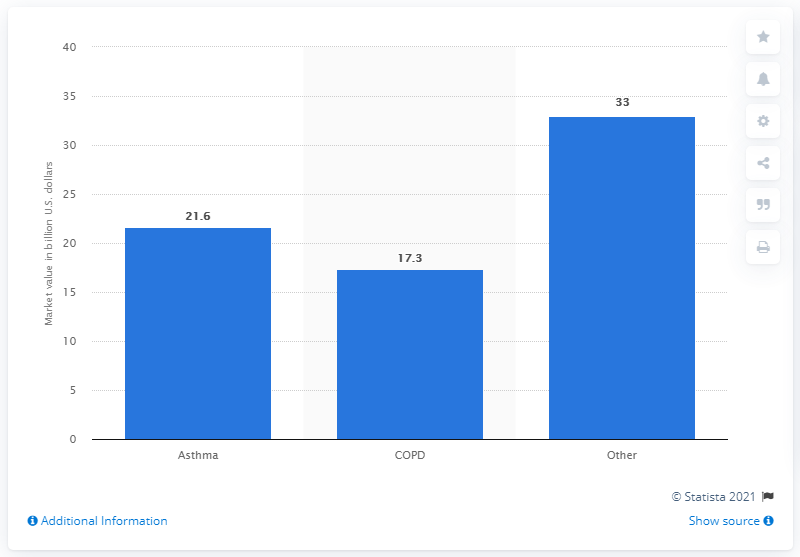Mention a couple of crucial points in this snapshot. The global asthma therapy market generated $21.6 million in the third quarter of 2020. 